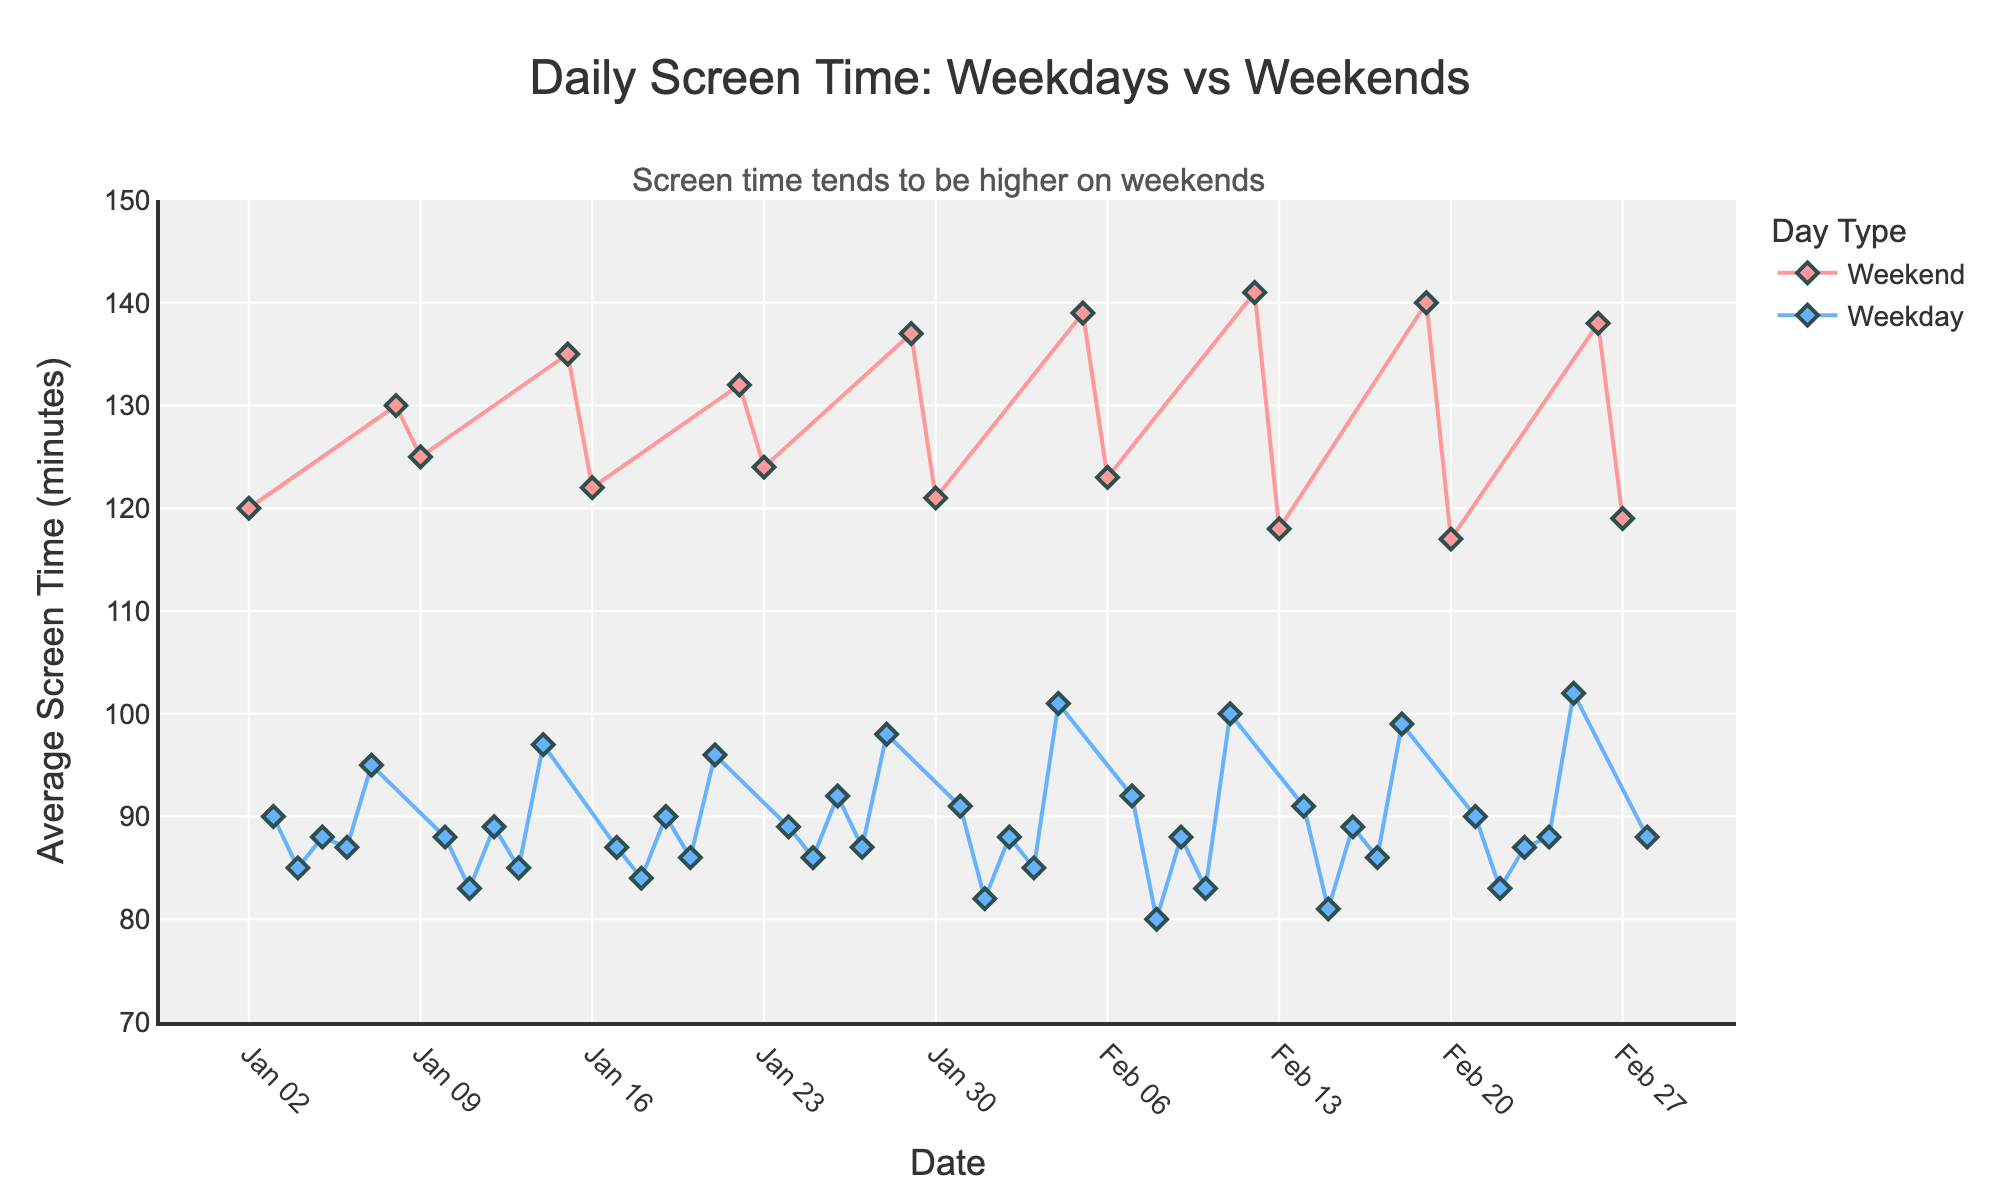What is the title of the figure? The title of the figure is displayed at the top of the chart and reads "Daily Screen Time: Weekdays vs Weekends".
Answer: Daily Screen Time: Weekdays vs Weekends Which color represents the weekdays in the chart? By examining the color associated with the lines and markers in the chart legend, we can see that weekdays are represented in blue.
Answer: Blue On which day category (weekend or weekday) does higher screen time tend to occur? The annotation at the top of the chart indicates that screen time tends to be higher on the weekends. This is also visually confirmed by the higher markers typically seen on weekends.
Answer: Weekend What is the average screen time on the first Sunday recorded in the data? By locating the first Sunday in the data series, which is January 2, 2022, we can read the average screen time value from the chart, which is 120 minutes.
Answer: 120 minutes How does the screen time on Saturdays compare to the screen time on weekdays in general? By comparing the plotted screen time values for Saturdays (red markers) and weekdays (blue markers), it is evident that Saturdays generally have higher screen time values.
Answer: Higher on Saturdays What is the average screen time difference between weekends and weekdays? To find the average screen time for weekends and weekdays, we sum and divide the screen time values for each category separately, then subtract the weekday average from the weekend average.
- Average for weekends: (120 + 130 + 125 + 135 + 122 + 132 + 124 + 137 + 121 + 139 + 123 + 141 + 118 + 140 + 117 + 138 + 119) / 17 = 128.65 minutes
- Average for weekdays: (90 + 85 + 88 + 87 + 95 + 88 + 83 + 89 + 85 + 97 + 87 + 84 + 90 + 86 + 96 + 91 + 82 + 88 + 85 + 101 + 92 + 80 + 88 + 83 + 99 + 90 + 83 + 87 + 88 + 102 + 88) / 31 = 89 minutes
- Difference = 128.65 - 89 = 39.65
Answer: 39.65 minutes Which date shows the highest recorded screen time? By locating the highest marker on the chart, we see it is February 12, 2022, with a screen time of 141 minutes.
Answer: February 12, 2022 What is the trend for screen time during the weekdays over the past year? By observing the blue markers and lines over time, it can be noted that there is no significant increasing or decreasing trend in weekday screen time, with values staying relatively stable around 85-95 minutes.
Answer: Stable Are there any significant spikes or drops in screen time on weekends? The plot shows that screen time does not significantly fluctuate on weekends, with values generally maintained between 120 and 141 minutes.
Answer: No significant fluctuation 